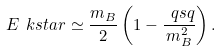Convert formula to latex. <formula><loc_0><loc_0><loc_500><loc_500>E _ { \ } k s t a r \simeq \frac { m _ { B } } { 2 } \left ( 1 - \frac { \ q s q } { m _ { B } ^ { 2 } } \right ) .</formula> 